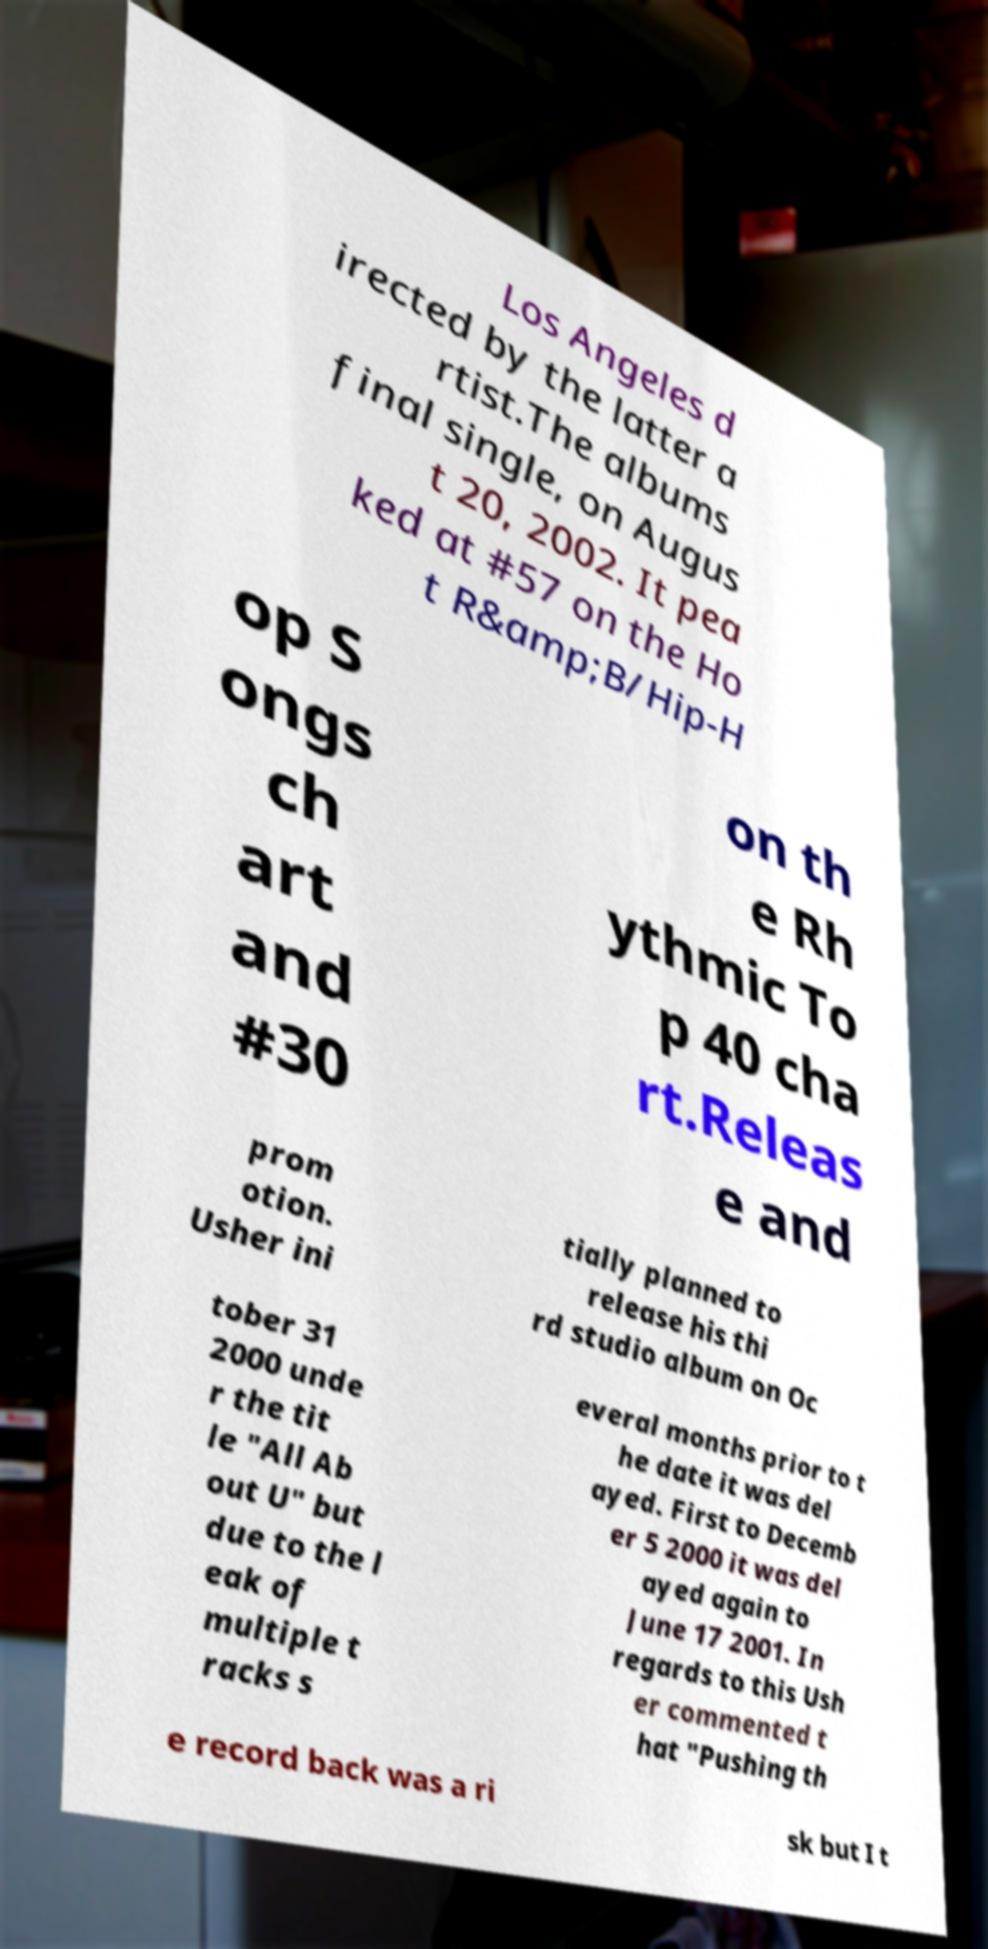I need the written content from this picture converted into text. Can you do that? Los Angeles d irected by the latter a rtist.The albums final single, on Augus t 20, 2002. It pea ked at #57 on the Ho t R&amp;B/Hip-H op S ongs ch art and #30 on th e Rh ythmic To p 40 cha rt.Releas e and prom otion. Usher ini tially planned to release his thi rd studio album on Oc tober 31 2000 unde r the tit le "All Ab out U" but due to the l eak of multiple t racks s everal months prior to t he date it was del ayed. First to Decemb er 5 2000 it was del ayed again to June 17 2001. In regards to this Ush er commented t hat "Pushing th e record back was a ri sk but I t 